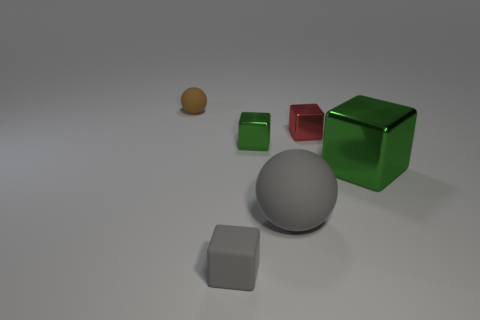Add 2 big green cubes. How many objects exist? 8 Subtract all cubes. How many objects are left? 2 Subtract 1 gray blocks. How many objects are left? 5 Subtract all gray cubes. Subtract all tiny green metallic objects. How many objects are left? 4 Add 4 brown rubber spheres. How many brown rubber spheres are left? 5 Add 2 tiny matte balls. How many tiny matte balls exist? 3 